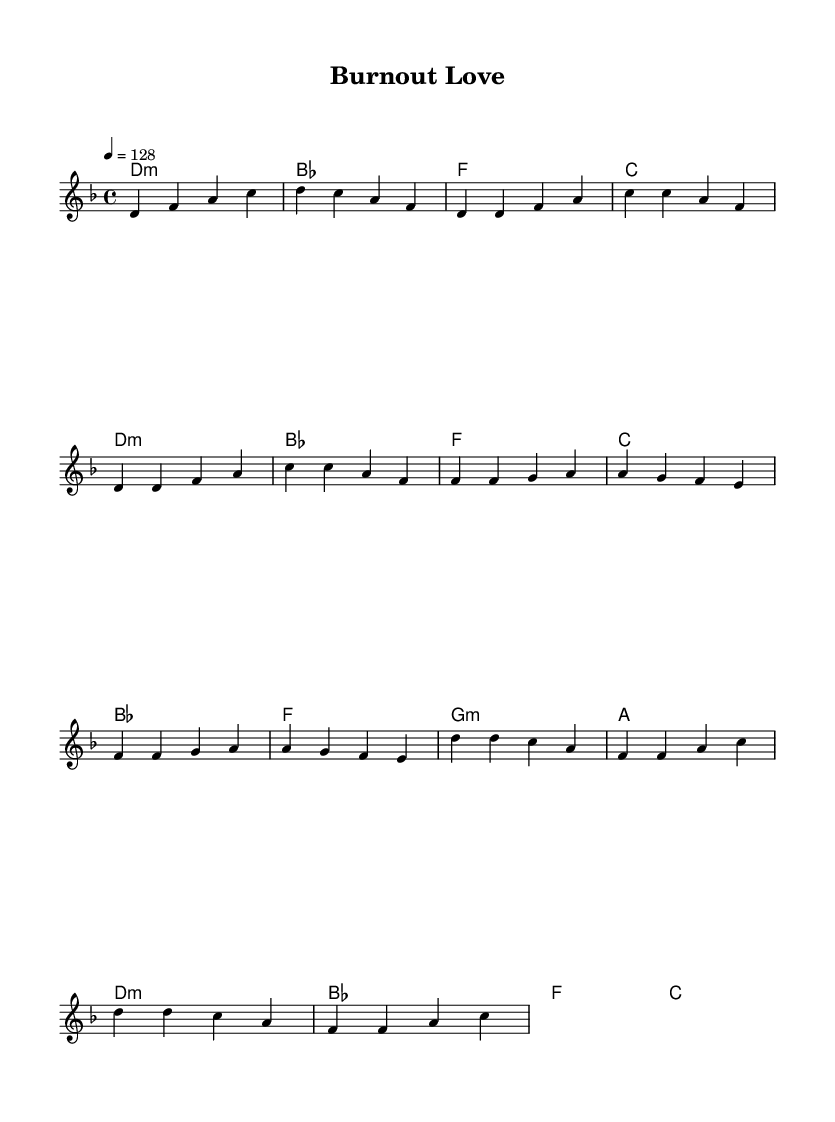What is the key signature of this music? The key signature indicated at the beginning of the score is D minor, which typically includes one flat (B flat) and has a relative major of F major.
Answer: D minor What is the time signature of this music? The time signature is shown next to the key signature, indicating how beats are grouped in each measure. In this case, it is 4/4, meaning there are four beats per measure with a quarter note receiving one beat.
Answer: 4/4 What is the tempo marking for this piece? The tempo marking, found in the global section of the score, tells us the speed of the music. It specifies "4 = 128," meaning there are 128 beats per minute in a quarter note.
Answer: 128 How many measures are in the Chorus section? By reviewing the score, we count the measures specifically under the chorus lyric section: it consists of four measures in total, following the usual pop structure.
Answer: 4 What type of chords are predominantly used in the harmony? The harmony section features various chords primarily, including minor and major chords. Specifically, we see D minor and B flat major, indicating a mixture of both minor and major tonalities.
Answer: Minor and major What is the main theme of the lyrics in this piece? The lyrics describe a racing and car-themed love, emphasizing speed and passion. By analyzing the words, it's evident that the text expresses a relatable excitement associated with racing and relationships.
Answer: Racing love How does the pre-chorus relate to the verse musically? The pre-chorus transitions smoothly from the verse by maintaining a similar rhythmic structure but introduces slightly different melodic phrases to build intensity leading into the chorus. This technique is common in pop music to enhance the dynamic flow.
Answer: Builds intensity 